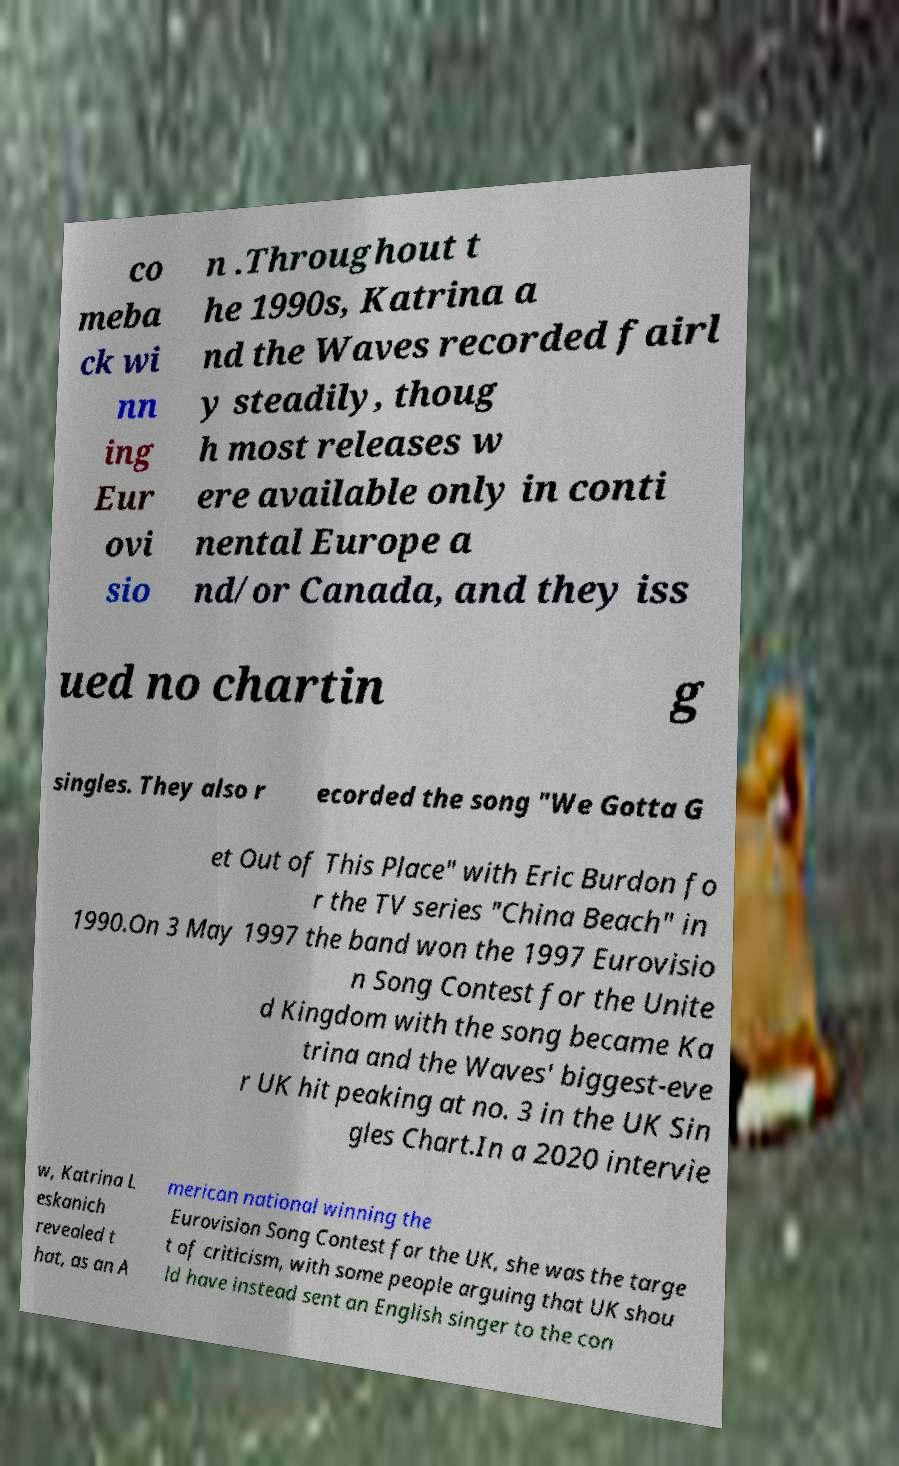What messages or text are displayed in this image? I need them in a readable, typed format. co meba ck wi nn ing Eur ovi sio n .Throughout t he 1990s, Katrina a nd the Waves recorded fairl y steadily, thoug h most releases w ere available only in conti nental Europe a nd/or Canada, and they iss ued no chartin g singles. They also r ecorded the song "We Gotta G et Out of This Place" with Eric Burdon fo r the TV series "China Beach" in 1990.On 3 May 1997 the band won the 1997 Eurovisio n Song Contest for the Unite d Kingdom with the song became Ka trina and the Waves' biggest-eve r UK hit peaking at no. 3 in the UK Sin gles Chart.In a 2020 intervie w, Katrina L eskanich revealed t hat, as an A merican national winning the Eurovision Song Contest for the UK, she was the targe t of criticism, with some people arguing that UK shou ld have instead sent an English singer to the con 